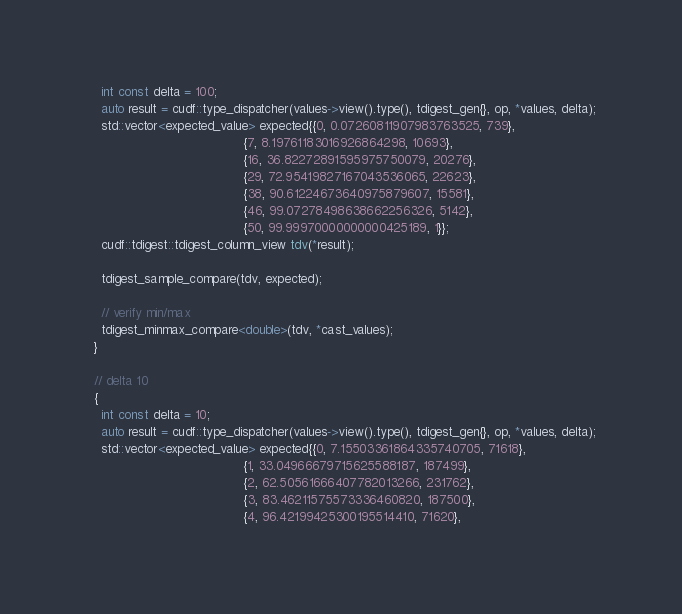<code> <loc_0><loc_0><loc_500><loc_500><_Cuda_>    int const delta = 100;
    auto result = cudf::type_dispatcher(values->view().type(), tdigest_gen{}, op, *values, delta);
    std::vector<expected_value> expected{{0, 0.07260811907983763525, 739},
                                         {7, 8.19761183016926864298, 10693},
                                         {16, 36.82272891595975750079, 20276},
                                         {29, 72.95419827167043536065, 22623},
                                         {38, 90.61224673640975879607, 15581},
                                         {46, 99.07278498638662256326, 5142},
                                         {50, 99.99970000000000425189, 1}};
    cudf::tdigest::tdigest_column_view tdv(*result);

    tdigest_sample_compare(tdv, expected);

    // verify min/max
    tdigest_minmax_compare<double>(tdv, *cast_values);
  }

  // delta 10
  {
    int const delta = 10;
    auto result = cudf::type_dispatcher(values->view().type(), tdigest_gen{}, op, *values, delta);
    std::vector<expected_value> expected{{0, 7.15503361864335740705, 71618},
                                         {1, 33.04966679715625588187, 187499},
                                         {2, 62.50561666407782013266, 231762},
                                         {3, 83.46211575573336460820, 187500},
                                         {4, 96.42199425300195514410, 71620},</code> 